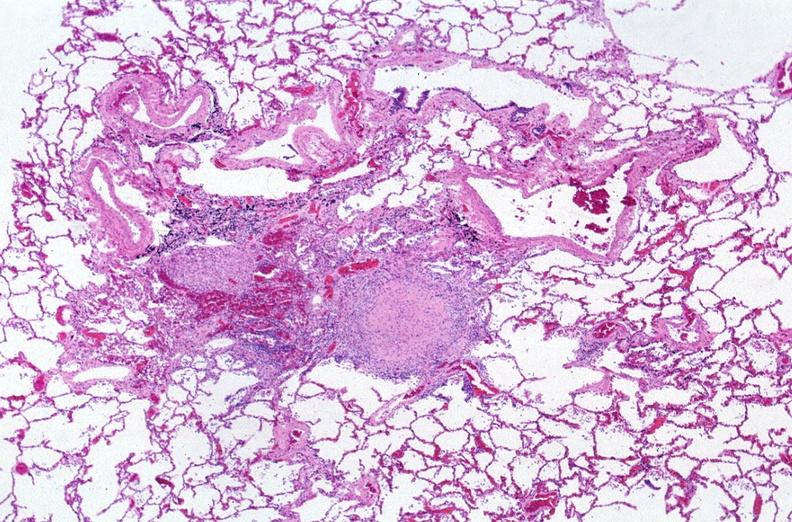does amyloid angiopathy r. endocrine show lung, mycobacterium tuberculosis, granulomas and giant cells?
Answer the question using a single word or phrase. No 